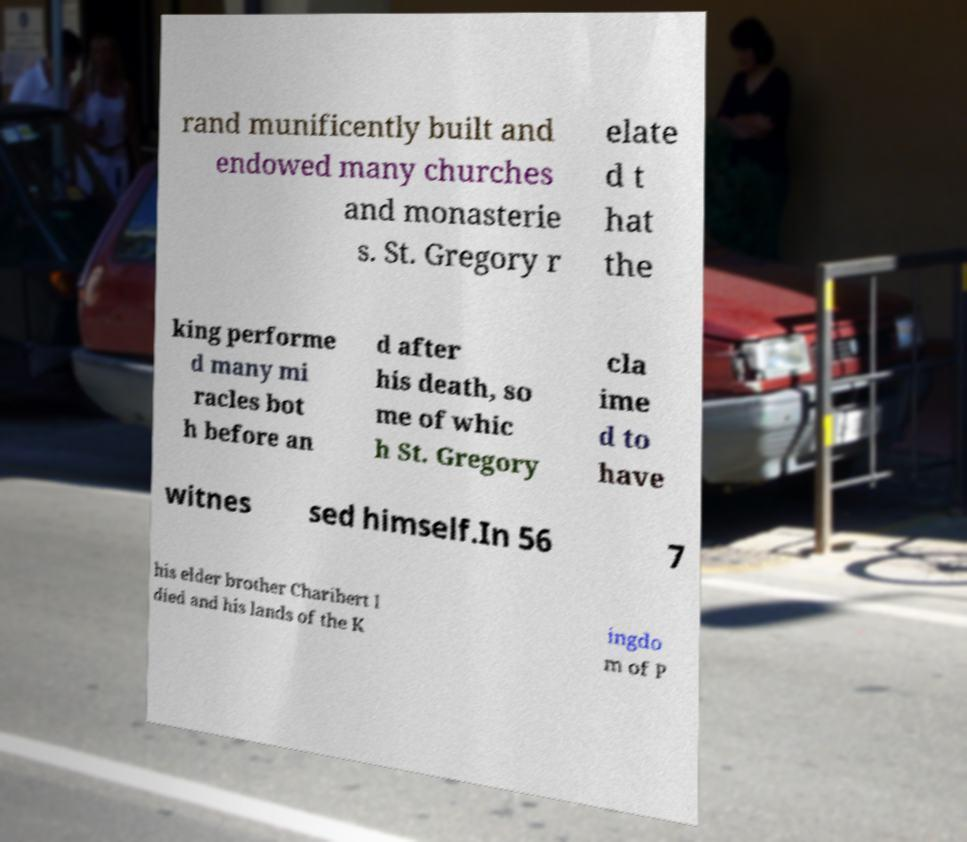There's text embedded in this image that I need extracted. Can you transcribe it verbatim? rand munificently built and endowed many churches and monasterie s. St. Gregory r elate d t hat the king performe d many mi racles bot h before an d after his death, so me of whic h St. Gregory cla ime d to have witnes sed himself.In 56 7 his elder brother Charibert I died and his lands of the K ingdo m of P 